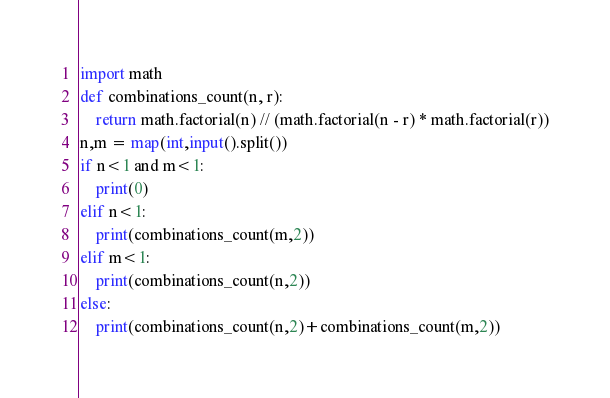<code> <loc_0><loc_0><loc_500><loc_500><_Python_>import math
def combinations_count(n, r):
    return math.factorial(n) // (math.factorial(n - r) * math.factorial(r))
n,m = map(int,input().split())
if n<1 and m<1:
    print(0)
elif n<1:
    print(combinations_count(m,2))
elif m<1:
    print(combinations_count(n,2))
else:
    print(combinations_count(n,2)+combinations_count(m,2))</code> 